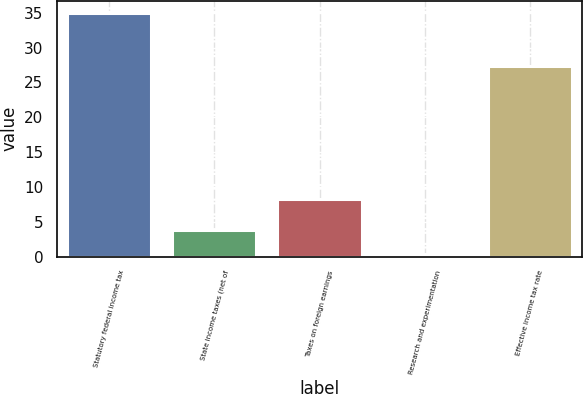Convert chart to OTSL. <chart><loc_0><loc_0><loc_500><loc_500><bar_chart><fcel>Statutory federal income tax<fcel>State income taxes (net of<fcel>Taxes on foreign earnings<fcel>Research and experimentation<fcel>Effective income tax rate<nl><fcel>35<fcel>3.86<fcel>8.3<fcel>0.4<fcel>27.3<nl></chart> 